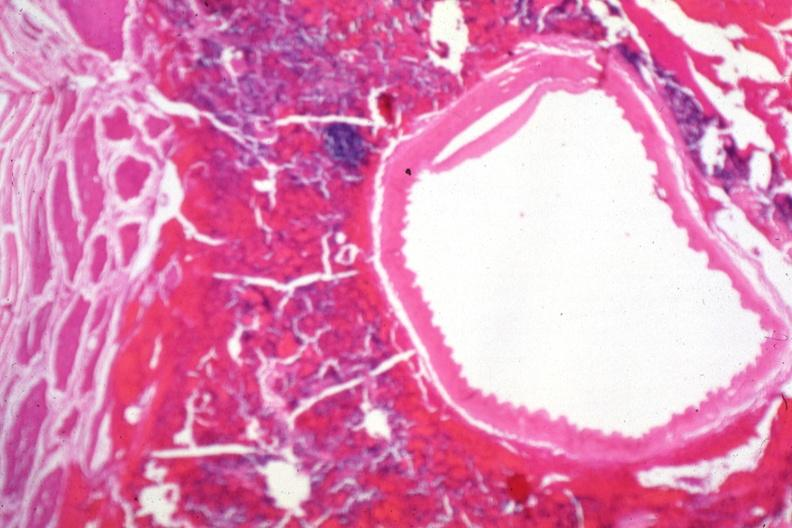what does this image show?
Answer the question using a single word or phrase. Carotid artery near sella with tumor cells in soft tissue 